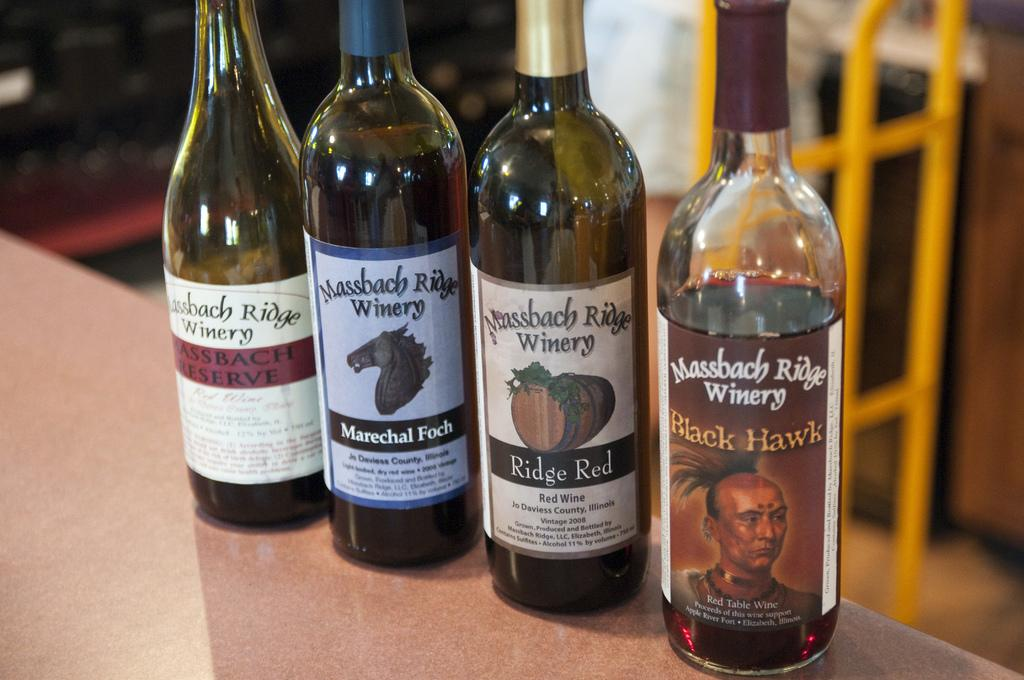<image>
Summarize the visual content of the image. some whiskey that has the word black on it 